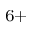<formula> <loc_0><loc_0><loc_500><loc_500>^ { 6 + }</formula> 